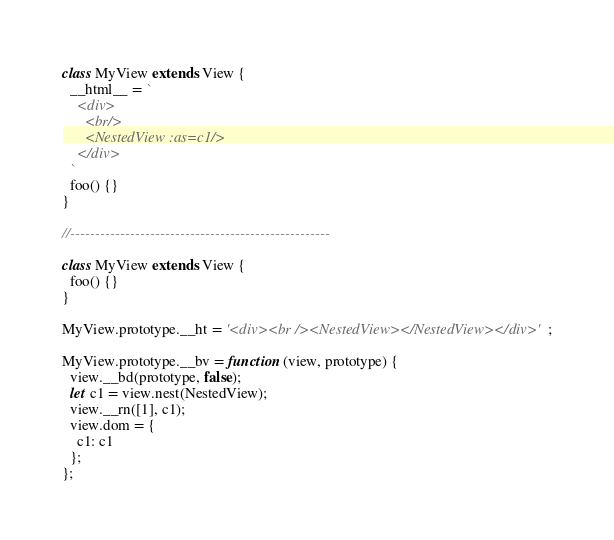Convert code to text. <code><loc_0><loc_0><loc_500><loc_500><_JavaScript_>class MyView extends View {
  __html__ = `
    <div>
      <br/>
      <NestedView :as=c1/>
    </div>
  `
  foo() {}
}

//----------------------------------------------------

class MyView extends View {
  foo() {}
}

MyView.prototype.__ht = '<div><br /><NestedView></NestedView></div>';

MyView.prototype.__bv = function (view, prototype) {
  view.__bd(prototype, false);
  let c1 = view.nest(NestedView);
  view.__rn([1], c1);
  view.dom = {
    c1: c1
  };
};</code> 